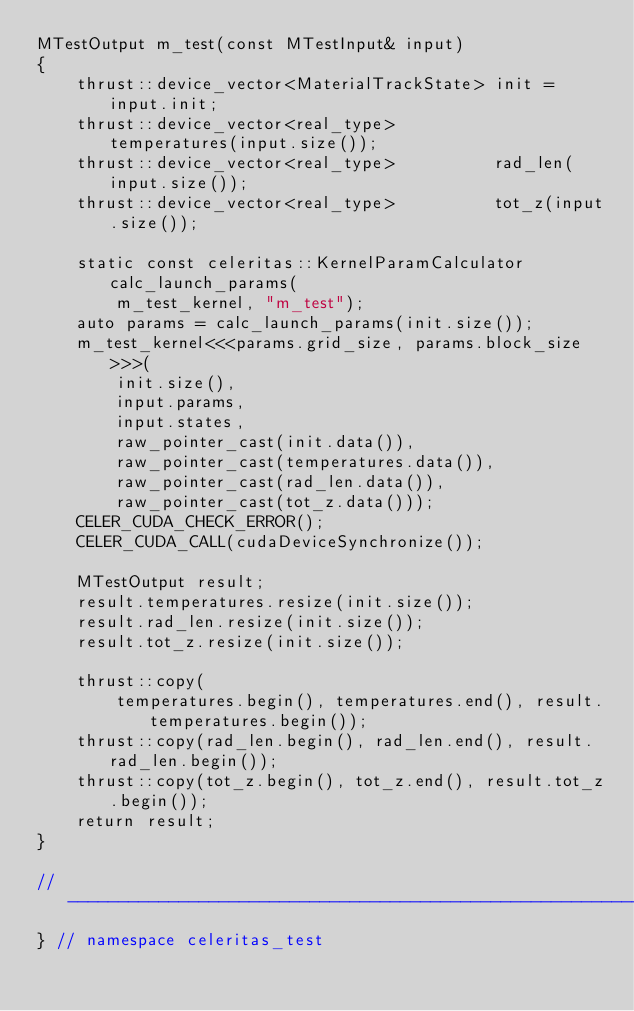Convert code to text. <code><loc_0><loc_0><loc_500><loc_500><_Cuda_>MTestOutput m_test(const MTestInput& input)
{
    thrust::device_vector<MaterialTrackState> init = input.init;
    thrust::device_vector<real_type>          temperatures(input.size());
    thrust::device_vector<real_type>          rad_len(input.size());
    thrust::device_vector<real_type>          tot_z(input.size());

    static const celeritas::KernelParamCalculator calc_launch_params(
        m_test_kernel, "m_test");
    auto params = calc_launch_params(init.size());
    m_test_kernel<<<params.grid_size, params.block_size>>>(
        init.size(),
        input.params,
        input.states,
        raw_pointer_cast(init.data()),
        raw_pointer_cast(temperatures.data()),
        raw_pointer_cast(rad_len.data()),
        raw_pointer_cast(tot_z.data()));
    CELER_CUDA_CHECK_ERROR();
    CELER_CUDA_CALL(cudaDeviceSynchronize());

    MTestOutput result;
    result.temperatures.resize(init.size());
    result.rad_len.resize(init.size());
    result.tot_z.resize(init.size());

    thrust::copy(
        temperatures.begin(), temperatures.end(), result.temperatures.begin());
    thrust::copy(rad_len.begin(), rad_len.end(), result.rad_len.begin());
    thrust::copy(tot_z.begin(), tot_z.end(), result.tot_z.begin());
    return result;
}

//---------------------------------------------------------------------------//
} // namespace celeritas_test
</code> 